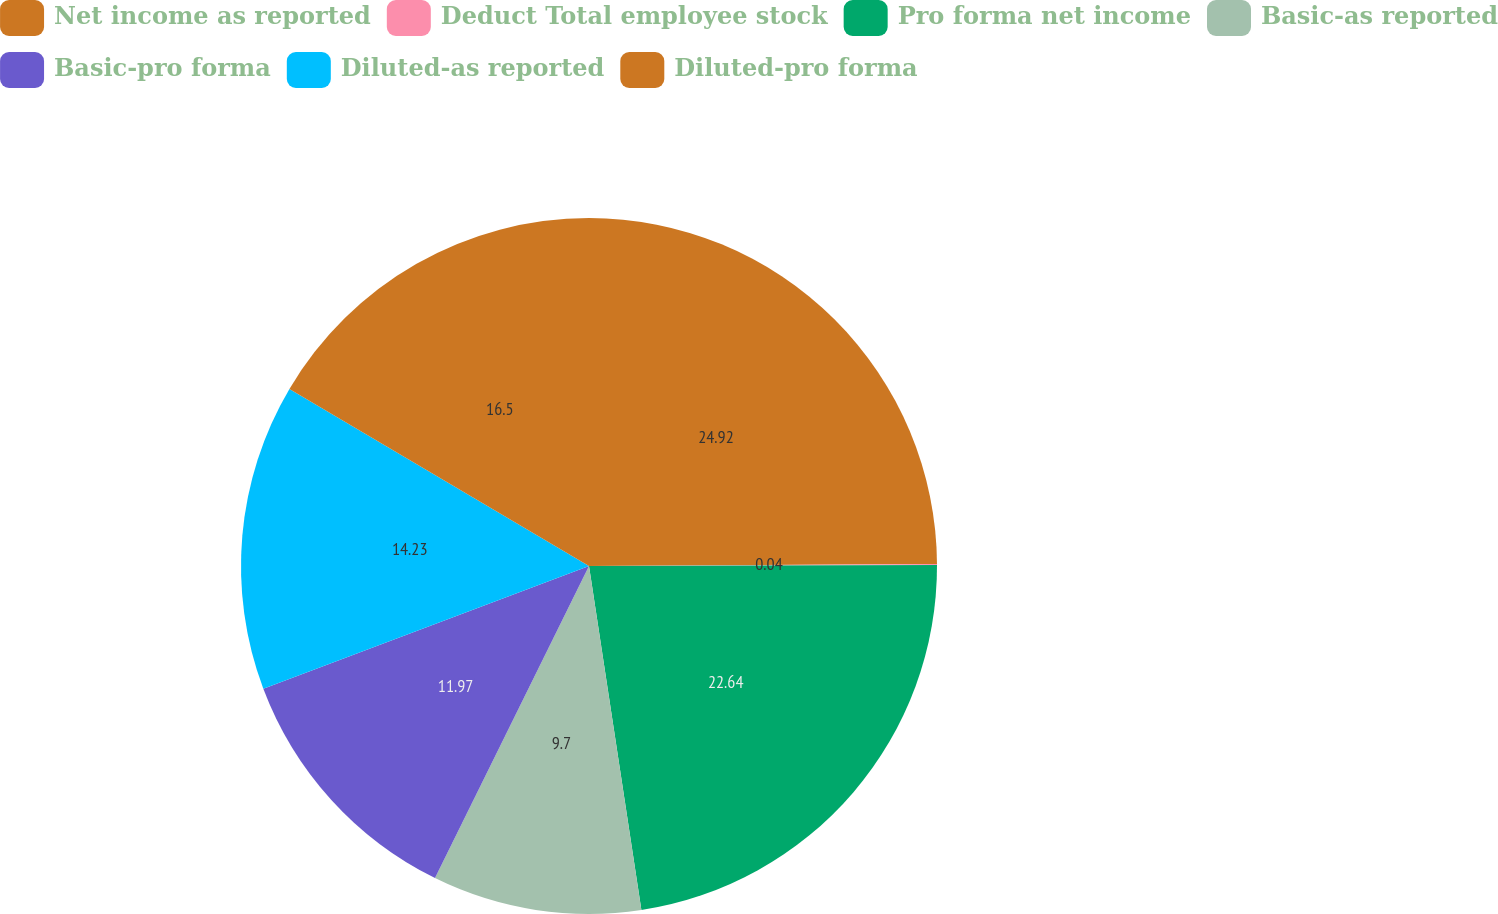<chart> <loc_0><loc_0><loc_500><loc_500><pie_chart><fcel>Net income as reported<fcel>Deduct Total employee stock<fcel>Pro forma net income<fcel>Basic-as reported<fcel>Basic-pro forma<fcel>Diluted-as reported<fcel>Diluted-pro forma<nl><fcel>24.91%<fcel>0.04%<fcel>22.64%<fcel>9.7%<fcel>11.97%<fcel>14.23%<fcel>16.5%<nl></chart> 